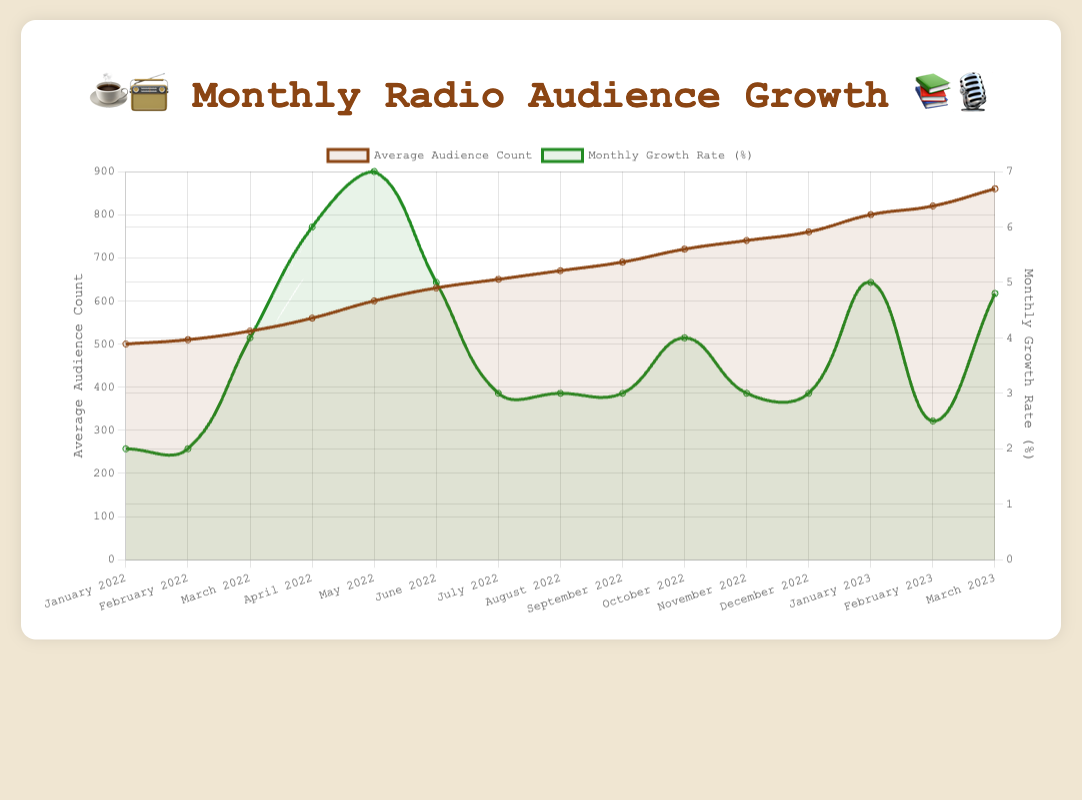What's the highest average audience count observed in the figure? The figure shows the average audience count for each month, and the highest point on the 'Average Audience Count' line represents the peak audience. The highest observed value is in March 2023 with an audience count of 860.
Answer: 860 Which month had the highest monthly growth rate in 2022? By examining the 'Monthly Growth Rate' line for 2022, we see that the highest point occurred in May with a growth rate of 7%.
Answer: May Compare the average audience counts of February 2022 and February 2023. Which is higher and by how much? February 2022 had an average audience count of 510, and February 2023 had an audience count of 820. The difference is 820 - 510 = 310. Thus, February 2023's audience count is higher by 310.
Answer: February 2023, higher by 310 What is the average monthly growth rate for 2022? To find the average growth rate for 2022, add up the monthly growth rates: 2 + 2 + 4 + 6 + 7 + 5 + 3 + 3 + 3 + 4 + 3 + 3 = 45. There are 12 months, so the average growth rate is 45 / 12 = 3.75%.
Answer: 3.75% Was there any month in 2023 with a lower monthly growth rate than the highest growth rate in 2022? The highest growth rate in 2022 was 7% (May). In 2023, the growth rates were 5% (January), 2.5% (February), and 4.8% (March). All these values are lower than 7%.
Answer: Yes What trend can you observe in the average audience count from January 2022 to March 2023? The line plot for 'Average Audience Count' shows a generally increasing trend from January 2022 (500) to March 2023 (860), with steady growth and no significant declines.
Answer: Increasing During which month(s) did the monthly growth rate first reach 4% and 6% in 2022? First, identify the 'Monthly Growth Rate' line for each month in 2022. It reached 4% in March and 6% in April.
Answer: March and April Which month had the highest average audience count in 2022 and what was the count? Observing the 'Average Audience Count' line for 2022, the highest point is in December with an audience count of 760.
Answer: December, 760 How much did the average audience count increase from January 2022 to January 2023? The average audience count in January 2022 was 500. In January 2023, it was 800. The increase is 800 - 500 = 300.
Answer: 300 In 2022, which author event had the smallest average audience count, and what was the count? The smallest average audience count in 2022 is observed in January with "Biographies" having an audience count of 500.
Answer: Biographies , 500 